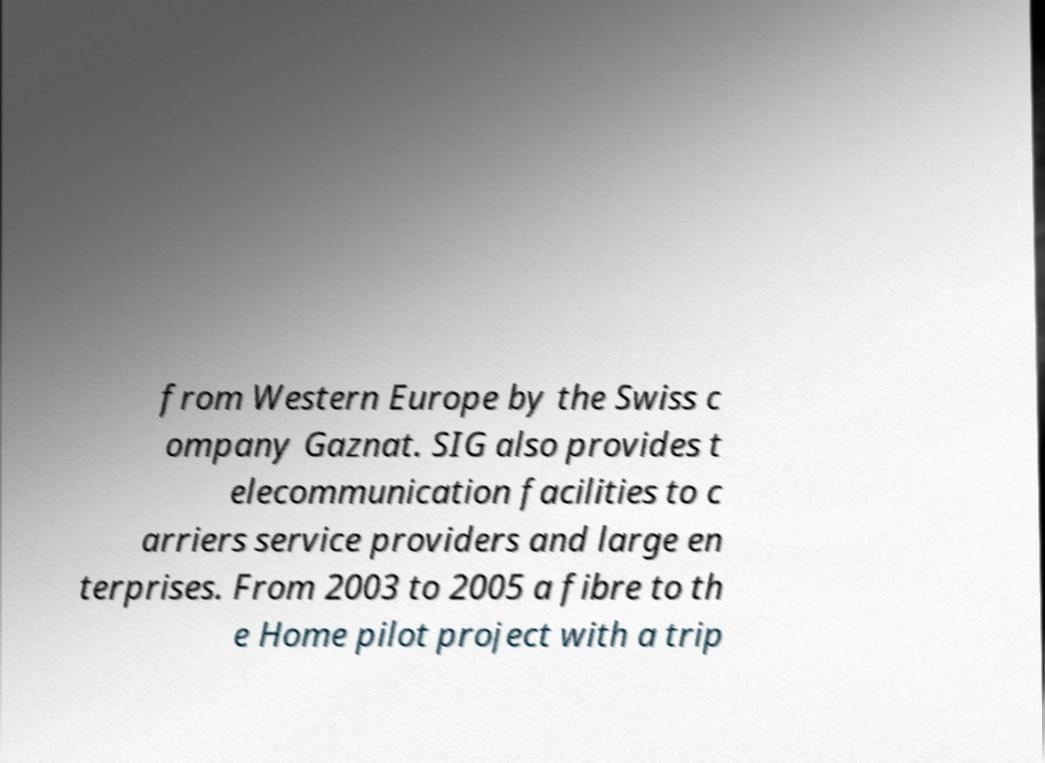Could you extract and type out the text from this image? from Western Europe by the Swiss c ompany Gaznat. SIG also provides t elecommunication facilities to c arriers service providers and large en terprises. From 2003 to 2005 a fibre to th e Home pilot project with a trip 